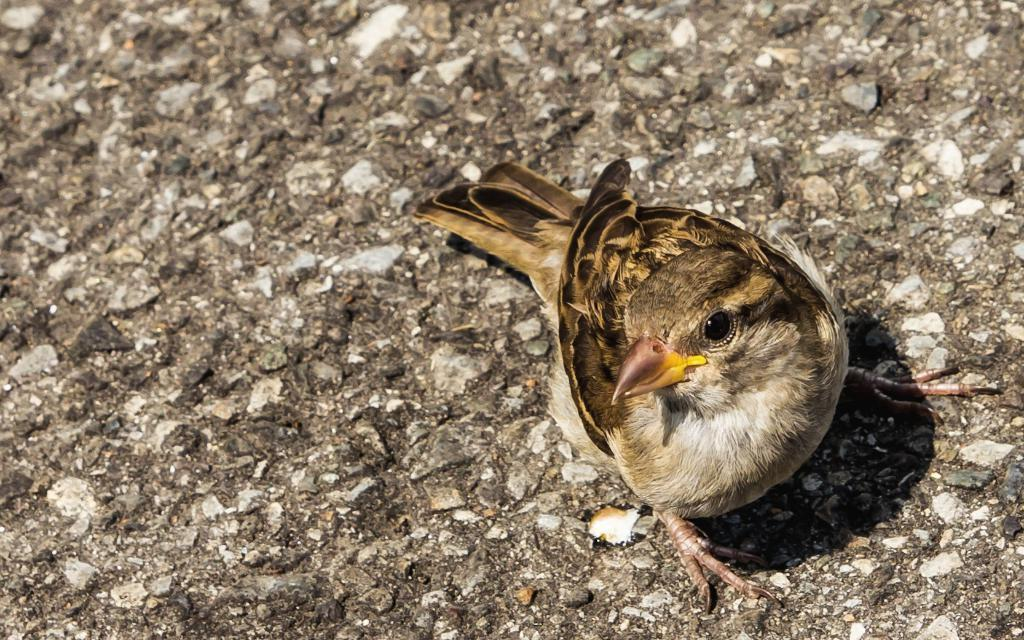What type of animal can be seen in the image? There is a bird in the image. Where is the bird located? The bird is on a platform. What type of fuel is the bird using to fly in the image? The bird is not flying in the image, so it is not using any fuel. 